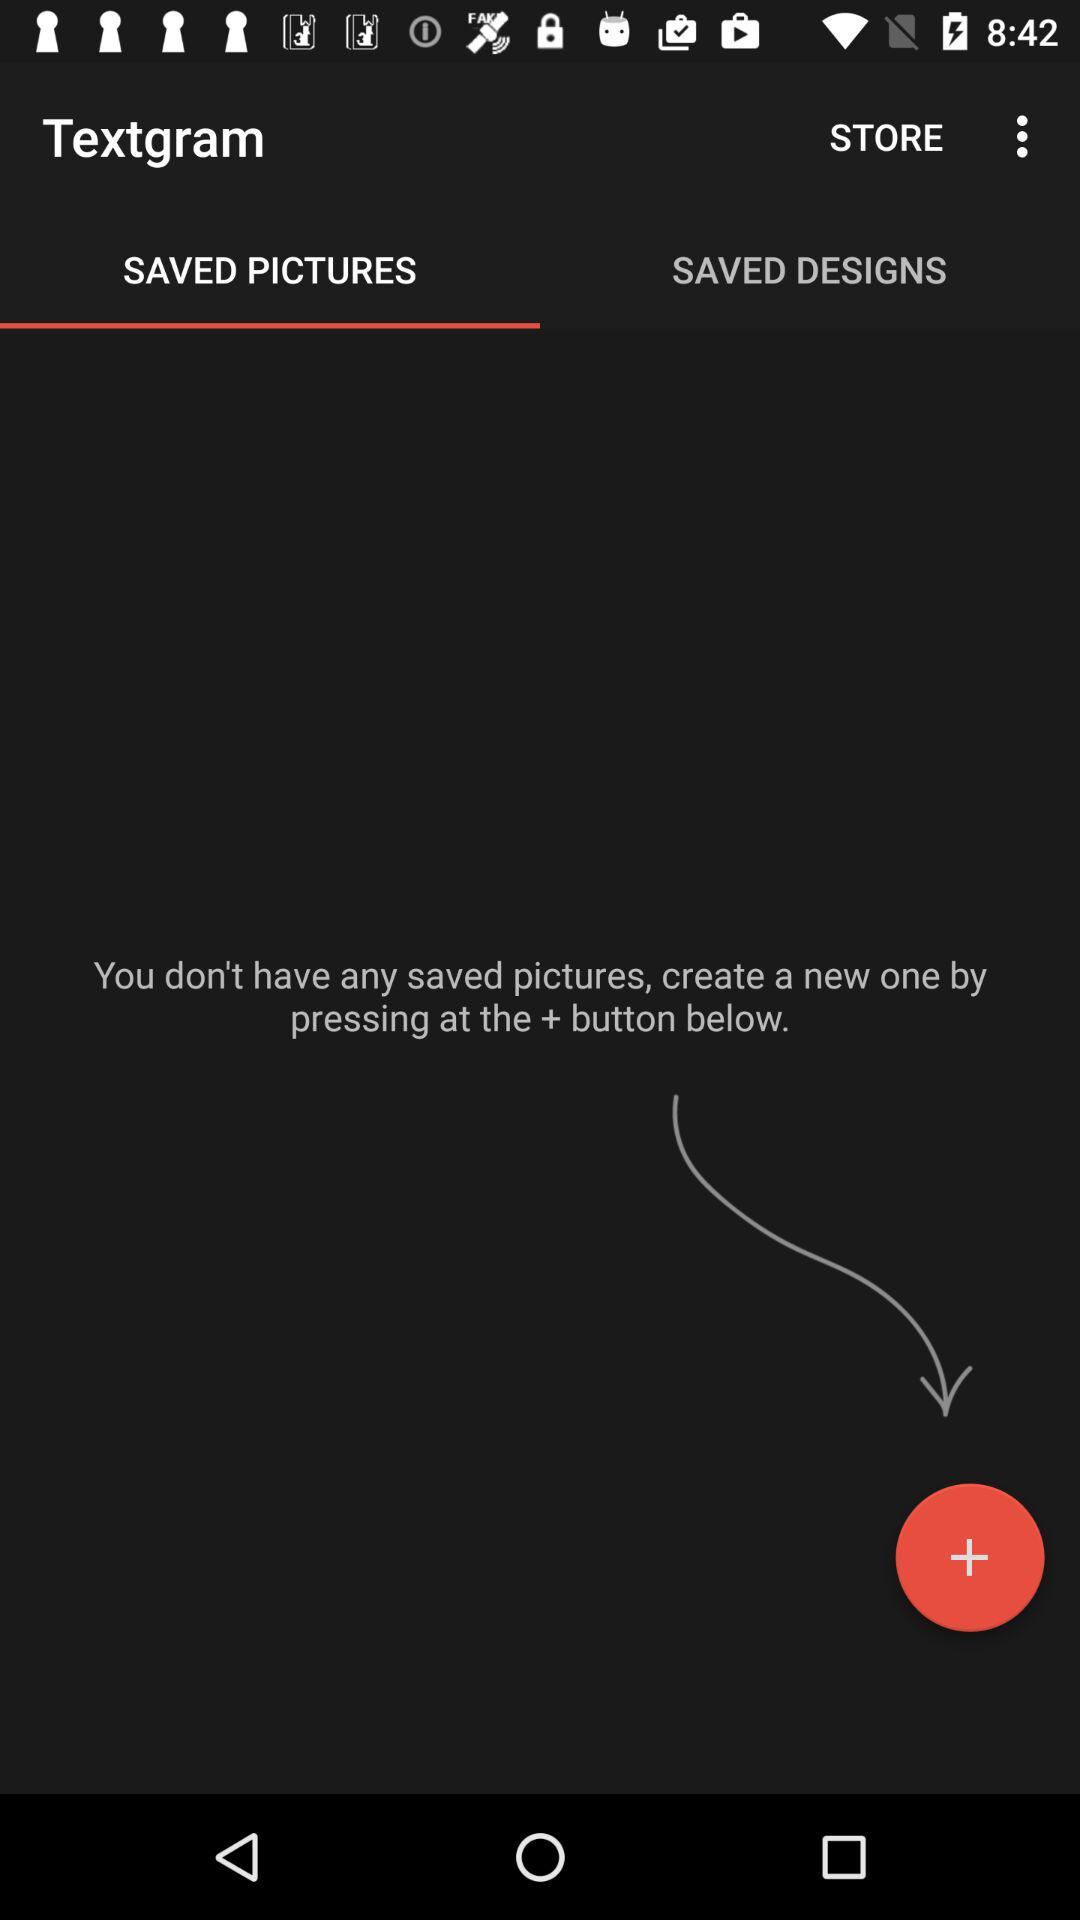How many saved pictures are there?
Answer the question using a single word or phrase. 0 